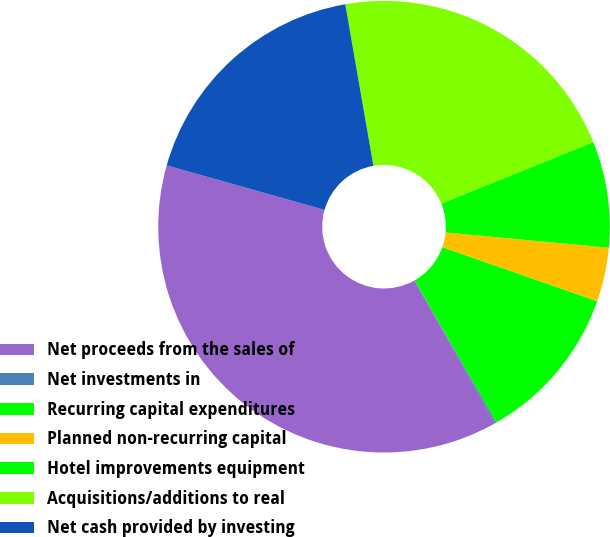Convert chart to OTSL. <chart><loc_0><loc_0><loc_500><loc_500><pie_chart><fcel>Net proceeds from the sales of<fcel>Net investments in<fcel>Recurring capital expenditures<fcel>Planned non-recurring capital<fcel>Hotel improvements equipment<fcel>Acquisitions/additions to real<fcel>Net cash provided by investing<nl><fcel>37.56%<fcel>0.12%<fcel>11.35%<fcel>3.86%<fcel>7.6%<fcel>21.63%<fcel>17.88%<nl></chart> 